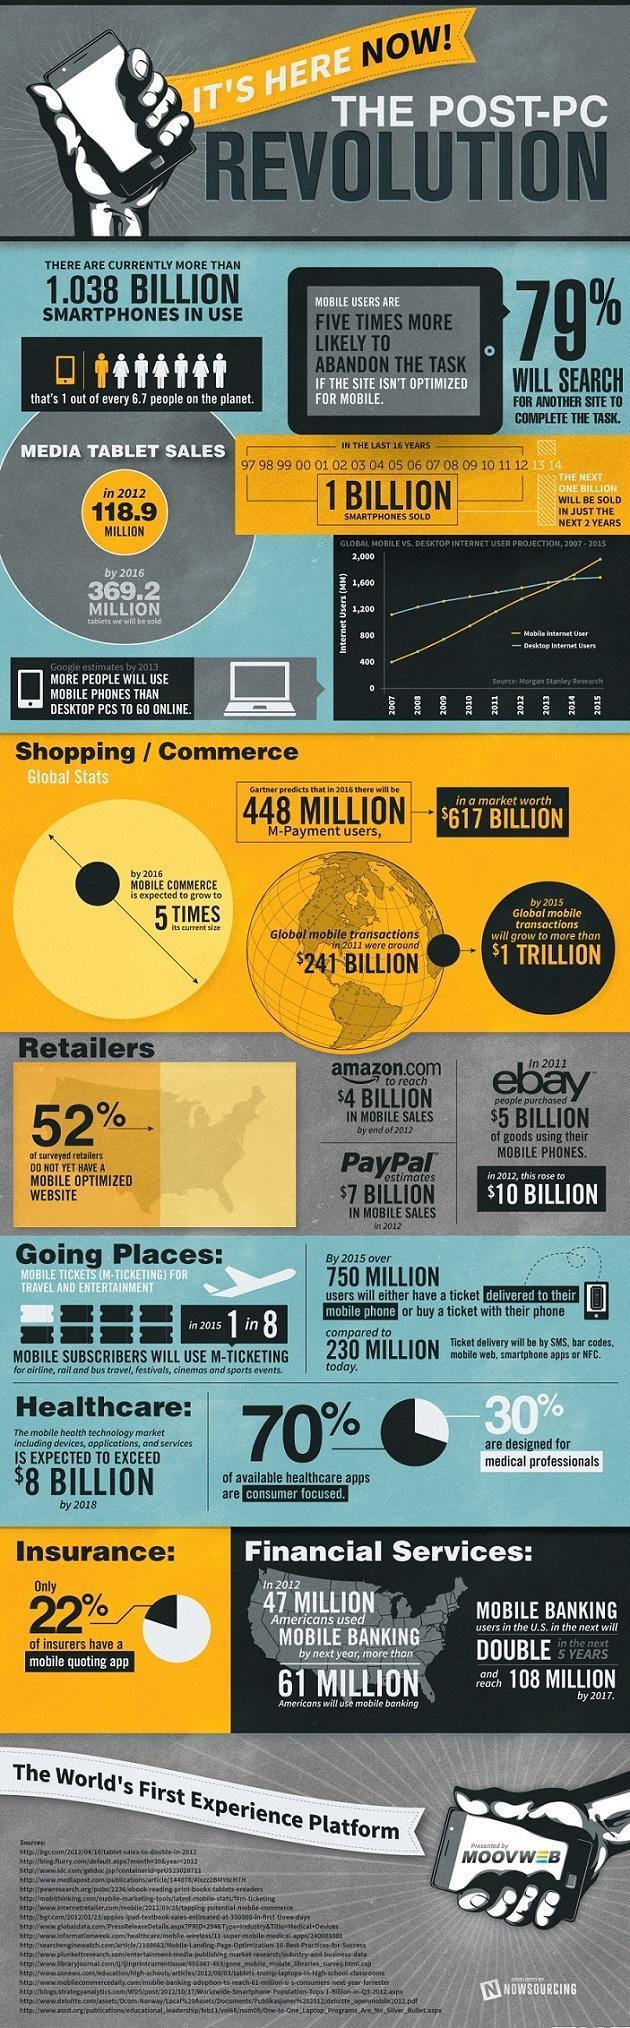What percentage of people will not search for another site to complete the task?
Answer the question with a short phrase. 21% What percentage of surveyed retailers have a mobile-optimized website? 48% 